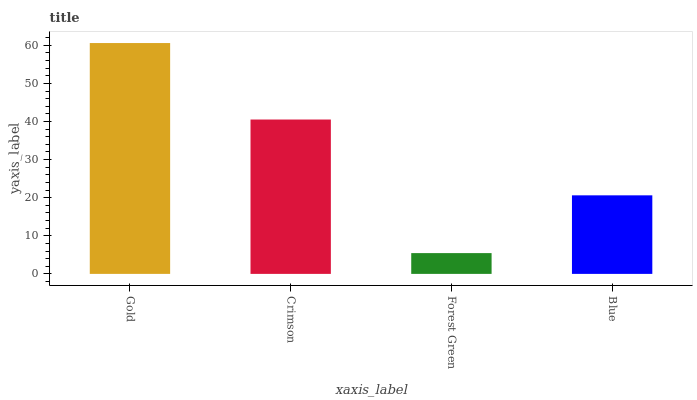Is Crimson the minimum?
Answer yes or no. No. Is Crimson the maximum?
Answer yes or no. No. Is Gold greater than Crimson?
Answer yes or no. Yes. Is Crimson less than Gold?
Answer yes or no. Yes. Is Crimson greater than Gold?
Answer yes or no. No. Is Gold less than Crimson?
Answer yes or no. No. Is Crimson the high median?
Answer yes or no. Yes. Is Blue the low median?
Answer yes or no. Yes. Is Blue the high median?
Answer yes or no. No. Is Gold the low median?
Answer yes or no. No. 